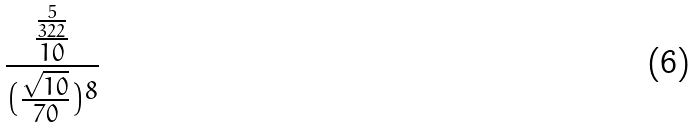<formula> <loc_0><loc_0><loc_500><loc_500>\frac { \frac { \frac { 5 } { 3 2 2 } } { 1 0 } } { ( \frac { \sqrt { 1 0 } } { 7 0 } ) ^ { 8 } }</formula> 